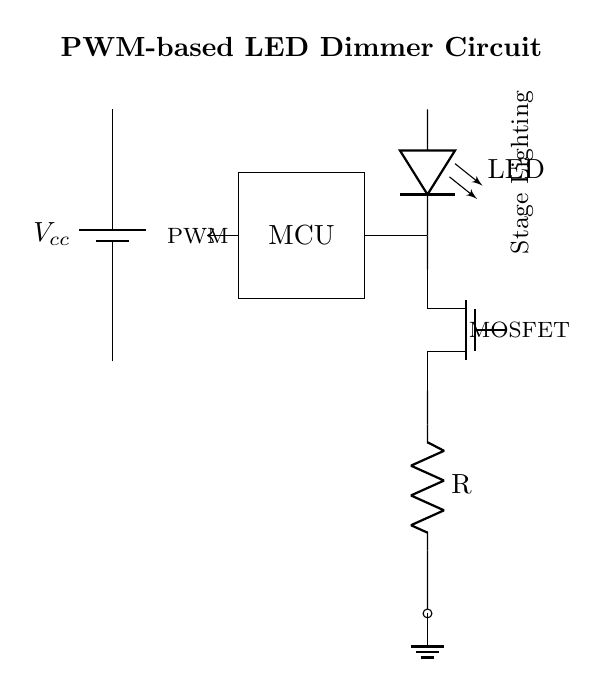What is the main function of the MOSFET in the circuit? The MOSFET acts as a switch that controls the power delivered to the LED by modulating the current flow, based on the PWM signal it receives from the microcontroller.
Answer: switch What component is used to limit the current to the LED? The resistor in the circuit limits the current going through the LED, preventing potential damage from excessive current.
Answer: resistor What kind of signal is applied to the MOSFET? The circuit diagram indicates that a PWM (Pulse Width Modulation) signal is applied to control the MOSFET, allowing for varying brightness levels of the LED.
Answer: PWM What does the abbreviation MCU stand for in this circuit? MCU stands for Microcontroller Unit, which is responsible for generating the PWM signal used to control the LED's brightness.
Answer: Microcontroller Unit How does the PWM signal affect the dimming of the LED? The PWM signal varies the duty cycle, or the on/off timing of the MOSFET, effectively controlling the average power delivered to the LED, which results in dimming effects.
Answer: Duty cycle What is the role of the battery in this circuit? The battery provides the necessary voltage (Vcc) to power the microcontroller and the LED, ensuring proper operation of the entire circuit.
Answer: power source 